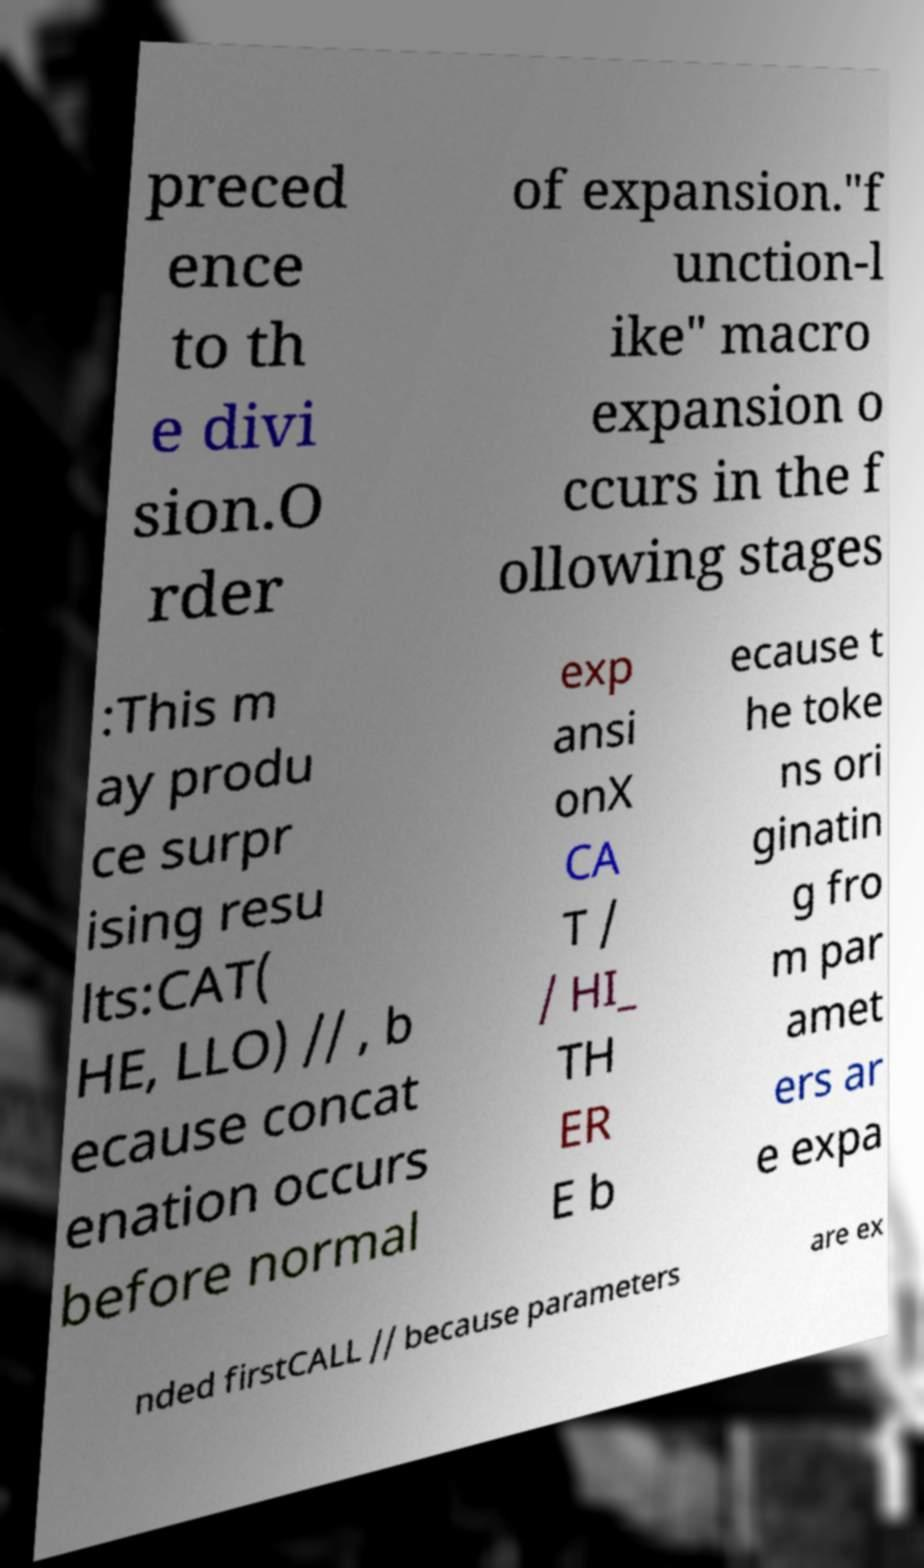Please read and relay the text visible in this image. What does it say? preced ence to th e divi sion.O rder of expansion."f unction-l ike" macro expansion o ccurs in the f ollowing stages :This m ay produ ce surpr ising resu lts:CAT( HE, LLO) // , b ecause concat enation occurs before normal exp ansi onX CA T / / HI_ TH ER E b ecause t he toke ns ori ginatin g fro m par amet ers ar e expa nded firstCALL // because parameters are ex 